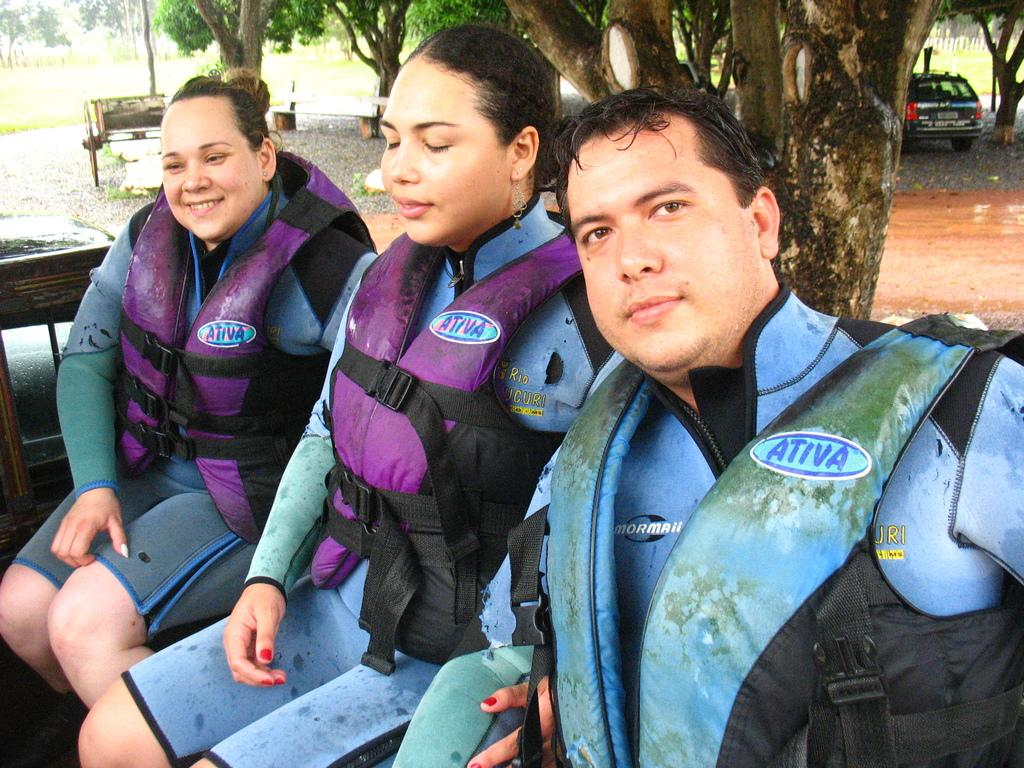How many people are in the image? There are three people in the image. What are the people wearing? The people are wearing jackets. What are the people doing in the image? The people are sitting. What type of objects can be seen made of wood in the image? There are wooden objects visible in the image. What mode of transportation is present in the image? A vehicle is present in the image. What can be seen in the background of the image? The tree trunk and trees are visible in the background. What type of pot is being used to stop the carriage in the image? There is no pot or carriage present in the image. 